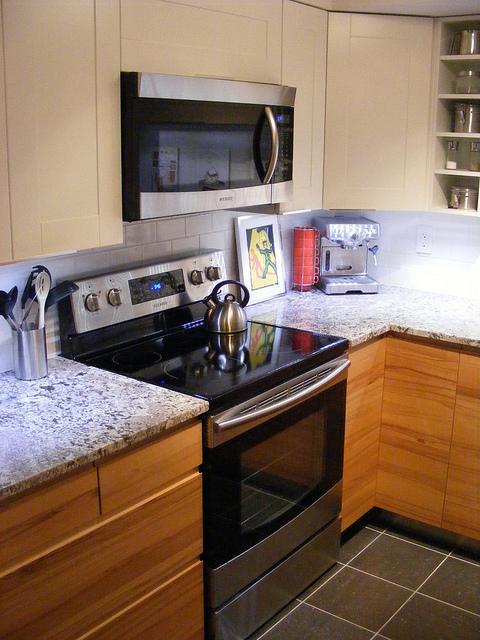How many brown scarfs does the man wear?
Give a very brief answer. 0. 